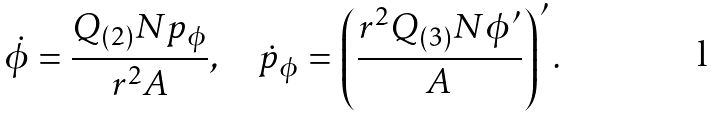Convert formula to latex. <formula><loc_0><loc_0><loc_500><loc_500>\dot { \phi } = \frac { Q _ { ( 2 ) } N p _ { \phi } } { r ^ { 2 } A } , \quad \dot { p } _ { \phi } = \left ( \frac { r ^ { 2 } Q _ { ( 3 ) } N \phi ^ { \prime } } { A } \right ) ^ { \prime } .</formula> 